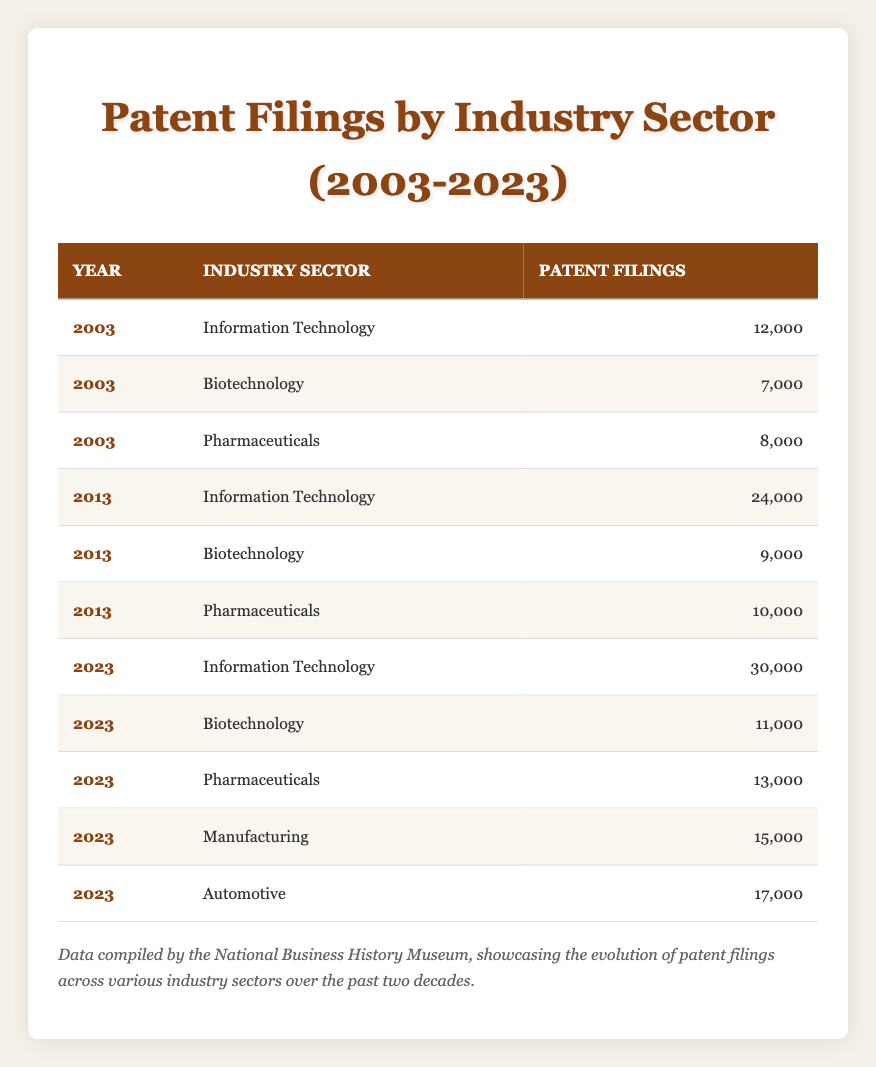What was the number of patent filings in the Information Technology sector in 2003? According to the table, in 2003, the patent filings for the Information Technology sector were listed as 12,000.
Answer: 12,000 What is the total number of patent filings in the Biotechnology sector from 2003 to 2023? The filings in 2003 were 7,000, in 2013 were 9,000, and in 2023 were 11,000. Adding these (7,000 + 9,000 + 11,000) gives a total of 27,000.
Answer: 27,000 Did the number of patent filings in Pharmaceuticals increase from 2003 to 2023? The number of filings in Pharmaceuticals was 8,000 in 2003 and increased to 13,000 in 2023. Therefore, it did increase.
Answer: Yes Which industry sector had the highest number of patent filings in 2023? In 2023, the Information Technology sector had 30,000 patent filings, which is higher than any other sector listed in that year.
Answer: Information Technology What was the average number of patent filings across all industry sectors in 2013? In 2013, the filings were 24,000 (Information Technology), 9,000 (Biotechnology), and 10,000 (Pharmaceuticals). The total is (24,000 + 9,000 + 10,000) = 43,000. The average is 43,000 divided by 3, which equals approximately 14,333.
Answer: 14,333 What is the percentage increase in patent filings for the Automotive sector from its absence to 2023? The Automotive sector did not have filings in the earlier years (2003 and 2013), and it recorded 17,000 filings in 2023, representing a substantial increase from zero. The percentage cannot be calculated as its former filings were nonexistent. Thus, it can be stated as an introduction rather than a percentage increase.
Answer: N/A Was there an industry sector that saw a decrease in patent filings over the analyzed years? By comparing the numbers from 2003 to 2023, all sectors show an increase in filings from their initial entries. There are no sectors where the number of filings decreased through the period.
Answer: No Find the difference in patent filings between the highest and lowest industries in 2023. In 2023, the highest filings were in Information Technology (30,000) and the lowest was Biotechnology (11,000). The difference is 30,000 - 11,000 = 19,000.
Answer: 19,000 What was the total number of patent filings for all sectors in 2023? For 2023, the filings are 30,000 (Information Technology), 11,000 (Biotechnology), 13,000 (Pharmaceuticals), 15,000 (Manufacturing), and 17,000 (Automotive). Adding these gives 30,000 + 11,000 + 13,000 + 15,000 + 17,000 = 86,000.
Answer: 86,000 